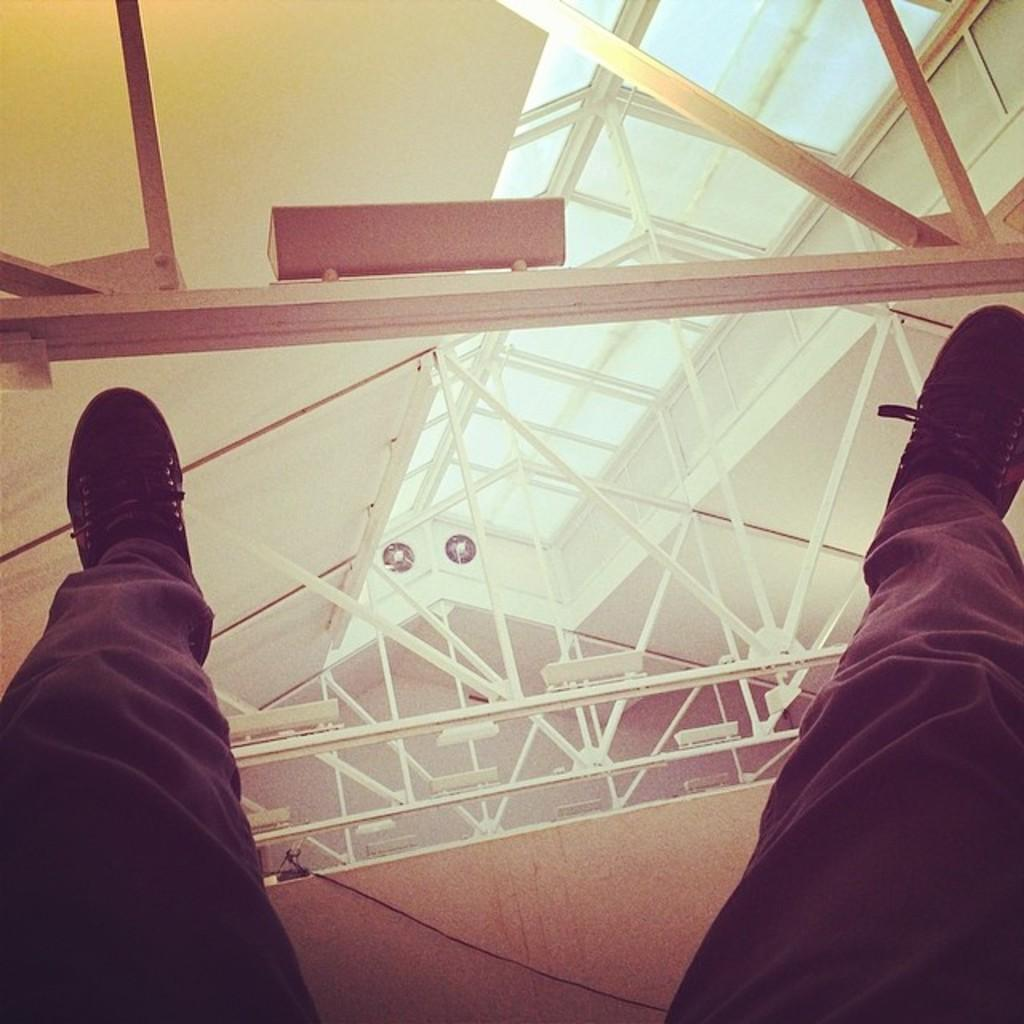What part of a person can be seen in the image? There are legs of a person visible in the image. What type of clothing is the person wearing on their legs? The person is wearing trousers. What type of footwear is the person wearing? The person is wearing shoes. What structure is visible in the image? There is a roof in the image. How many exhaust fans are present at the back in the image? There are two exhaust fans present at the back. What type of stick is the pig holding in the image? There is no pig or stick present in the image. 